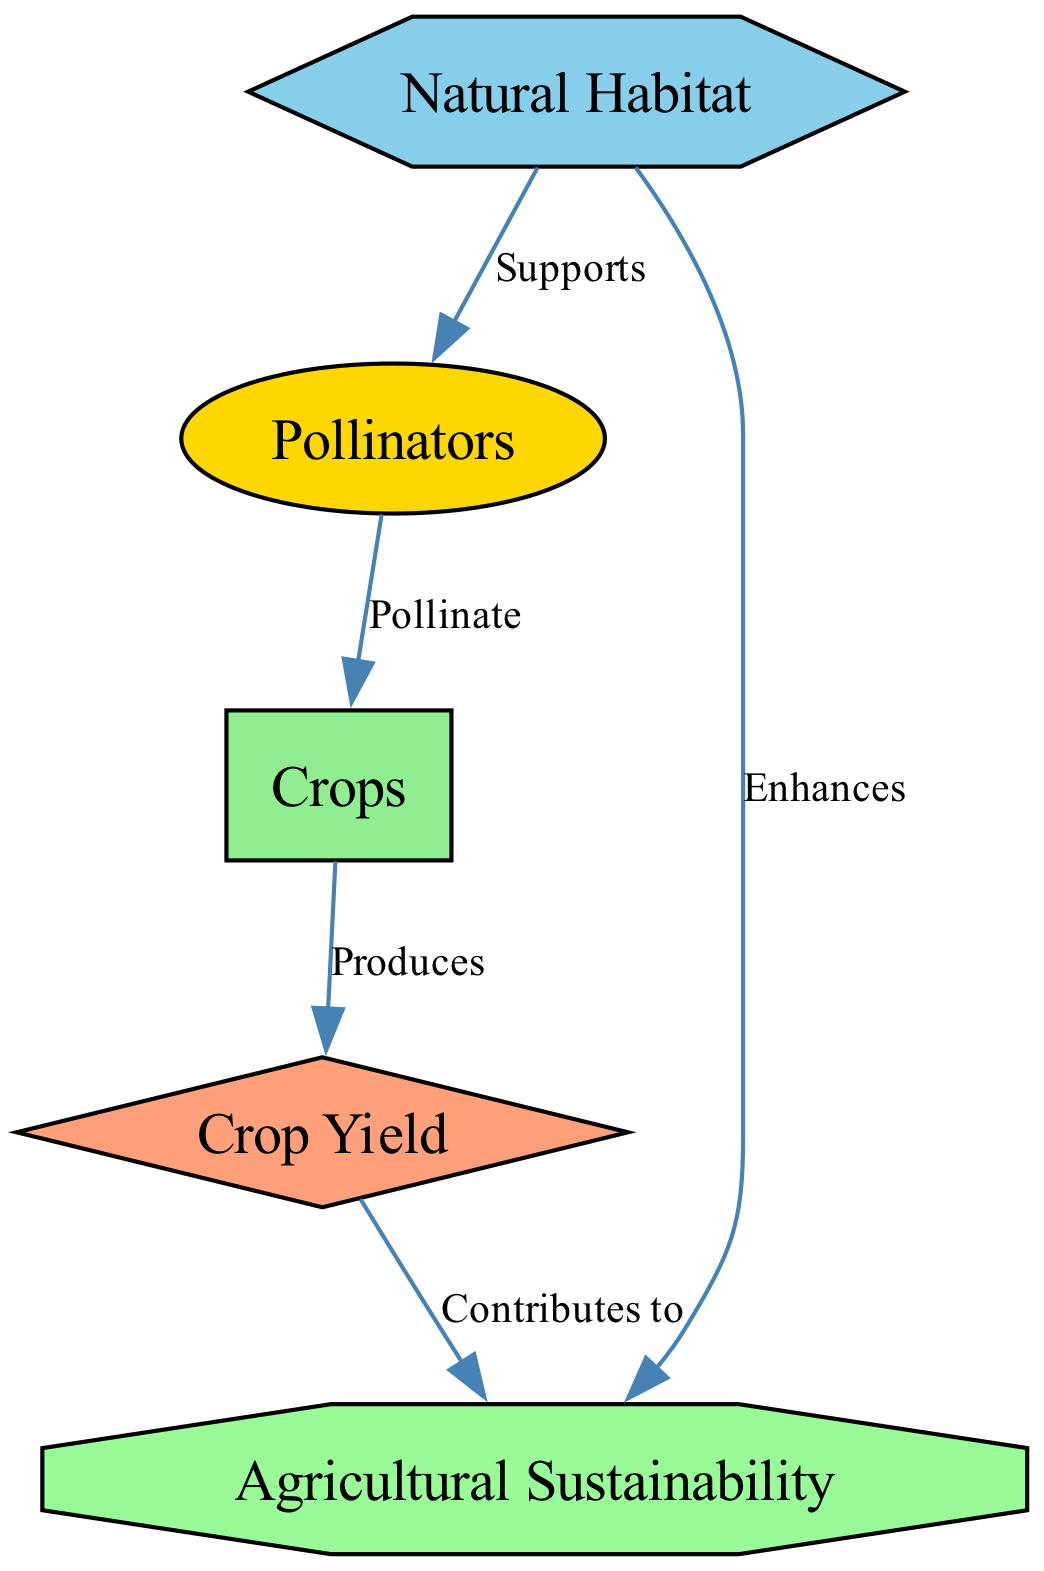What are the three types of pollinators listed in the diagram? The diagram mentions bees, butterflies, and other pollinating insects as pollinators. This information is directly obtained from the "Pollinators" node.
Answer: bees, butterflies, and other pollinating insects How many nodes are there in the diagram? The diagram has five nodes: crops, pollinators, habitat, yield, and sustainability. This is determined by counting the individual elements represented in the diagram.
Answer: 5 What does the habitat do for pollinators? According to the diagram, the habitat "Supports" pollinators. This is shown explicitly in the edge connecting the "habitat" node to the "pollinators" node, indicating a supportive relationship.
Answer: Supports What contributes to agricultural sustainability? The diagram shows that the "Crop Yield" contributes to "Agricultural Sustainability." This is seen through the arrow from "yield" to "sustainability," indicating a contribution relationship.
Answer: Crop Yield What type of habitat is mentioned in relation to the crops? The diagram lists "Natural Habitat" as being related to the surrounding area of crops. The node labeled "Natural Habitat" directly connects to the "pollinators," highlighting its ecological role.
Answer: Natural Habitat How many edges are in the diagram? The diagram has five edges: two links from "habitat" (to "pollinators" and "sustainability"), one from "pollinators" (to "crops"), one from "crops" (to "yield"), and one from "yield" (to "sustainability"). This indicates the connections between nodes.
Answer: 5 What is produced by the crops? The diagram indicates that "Crops" produces "Crop Yield." This is explicitly stated in the relationship seen through the edge connecting "crops" to "yield."
Answer: Crop Yield In what way does natural habitat enhance agricultural sustainability? The diagram states that the habitat "Enhances" agricultural sustainability, signifying a beneficial relationship. This is represented by the edge from "habitat" to "sustainability."
Answer: Enhances 